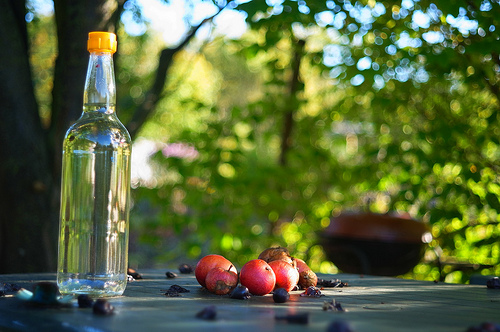How many apples are there? There are five apples grouped together on the table, set against a background where the sunlight filters through the verdant leaves of the surrounding trees. 